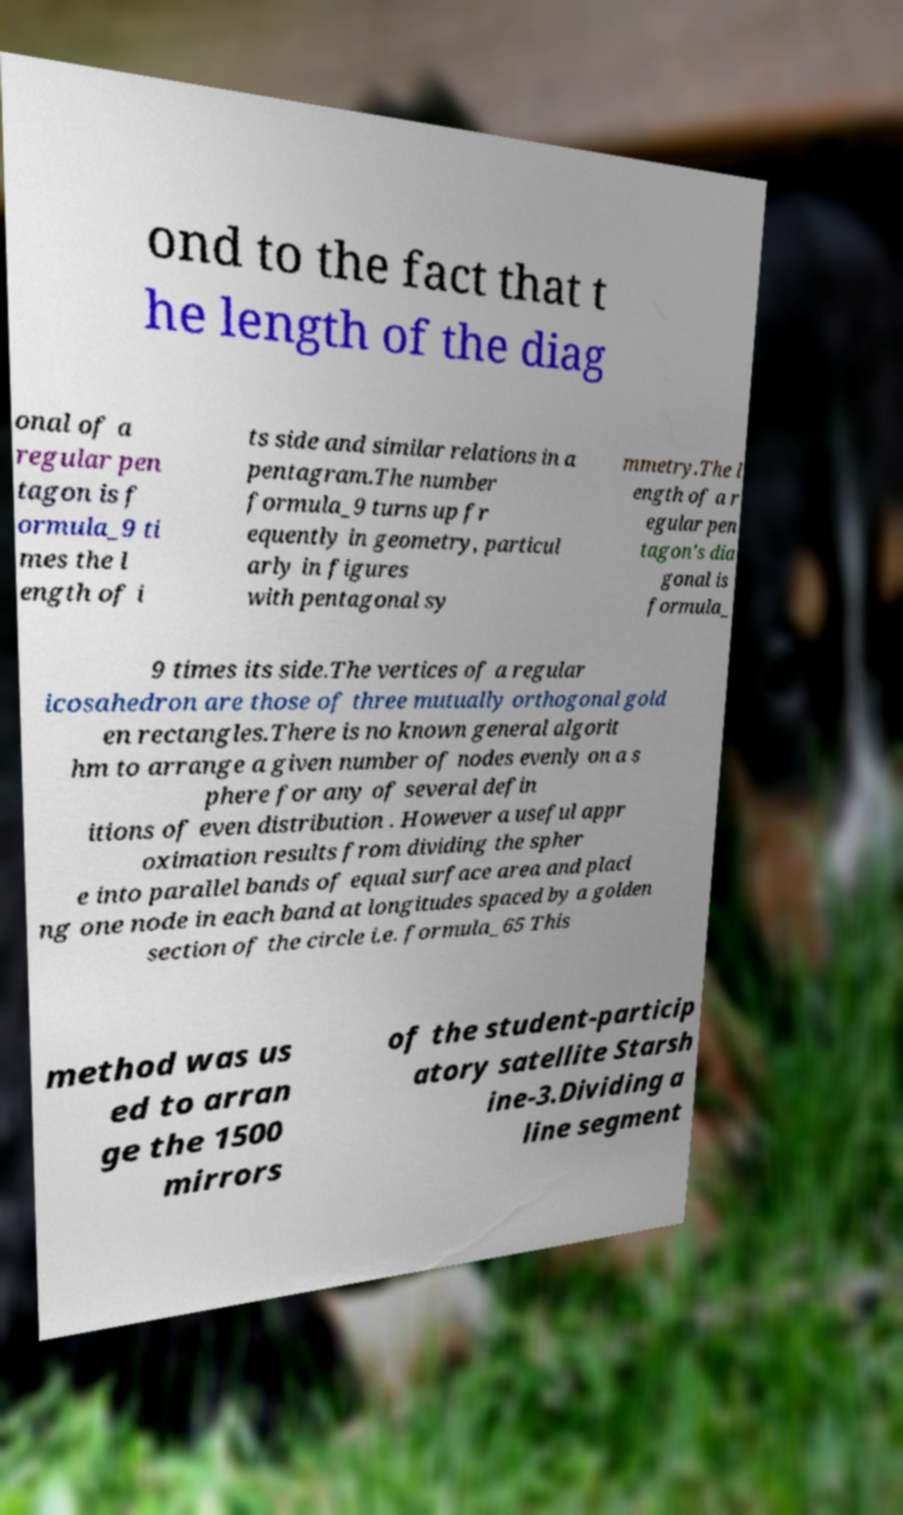Could you assist in decoding the text presented in this image and type it out clearly? ond to the fact that t he length of the diag onal of a regular pen tagon is f ormula_9 ti mes the l ength of i ts side and similar relations in a pentagram.The number formula_9 turns up fr equently in geometry, particul arly in figures with pentagonal sy mmetry.The l ength of a r egular pen tagon's dia gonal is formula_ 9 times its side.The vertices of a regular icosahedron are those of three mutually orthogonal gold en rectangles.There is no known general algorit hm to arrange a given number of nodes evenly on a s phere for any of several defin itions of even distribution . However a useful appr oximation results from dividing the spher e into parallel bands of equal surface area and placi ng one node in each band at longitudes spaced by a golden section of the circle i.e. formula_65 This method was us ed to arran ge the 1500 mirrors of the student-particip atory satellite Starsh ine-3.Dividing a line segment 